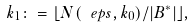<formula> <loc_0><loc_0><loc_500><loc_500>k _ { 1 } \colon = \lfloor N ( \ e p s , k _ { 0 } ) / | B ^ { * } | \rfloor ,</formula> 